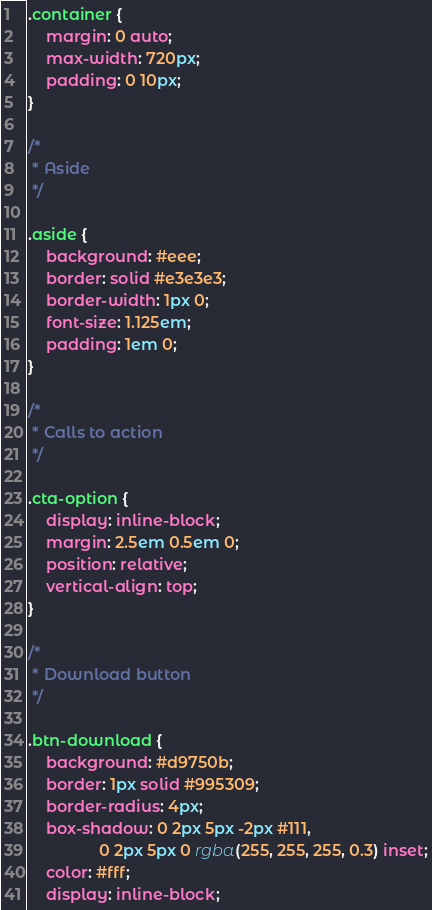<code> <loc_0><loc_0><loc_500><loc_500><_CSS_>
.container {
    margin: 0 auto;
    max-width: 720px;
    padding: 0 10px;
}

/*
 * Aside
 */

.aside {
    background: #eee;
    border: solid #e3e3e3;
    border-width: 1px 0;
    font-size: 1.125em;
    padding: 1em 0;
}

/*
 * Calls to action
 */

.cta-option {
    display: inline-block;
    margin: 2.5em 0.5em 0;
    position: relative;
    vertical-align: top;
}

/*
 * Download button
 */

.btn-download {
    background: #d9750b;
    border: 1px solid #995309;
    border-radius: 4px;
    box-shadow: 0 2px 5px -2px #111,
                0 2px 5px 0 rgba(255, 255, 255, 0.3) inset;
    color: #fff;
    display: inline-block;</code> 